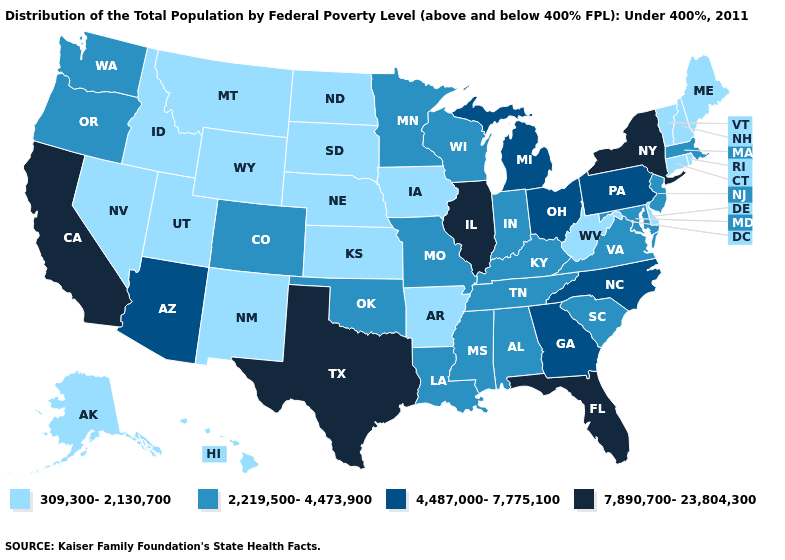What is the value of Pennsylvania?
Write a very short answer. 4,487,000-7,775,100. Does the first symbol in the legend represent the smallest category?
Give a very brief answer. Yes. What is the highest value in the South ?
Write a very short answer. 7,890,700-23,804,300. Which states have the highest value in the USA?
Answer briefly. California, Florida, Illinois, New York, Texas. Name the states that have a value in the range 7,890,700-23,804,300?
Short answer required. California, Florida, Illinois, New York, Texas. What is the value of Oklahoma?
Short answer required. 2,219,500-4,473,900. What is the value of North Carolina?
Concise answer only. 4,487,000-7,775,100. Which states have the lowest value in the MidWest?
Write a very short answer. Iowa, Kansas, Nebraska, North Dakota, South Dakota. What is the lowest value in the USA?
Concise answer only. 309,300-2,130,700. What is the value of New Mexico?
Keep it brief. 309,300-2,130,700. Which states have the highest value in the USA?
Keep it brief. California, Florida, Illinois, New York, Texas. Does the map have missing data?
Be succinct. No. Which states have the highest value in the USA?
Give a very brief answer. California, Florida, Illinois, New York, Texas. Does Illinois have the highest value in the MidWest?
Short answer required. Yes. 